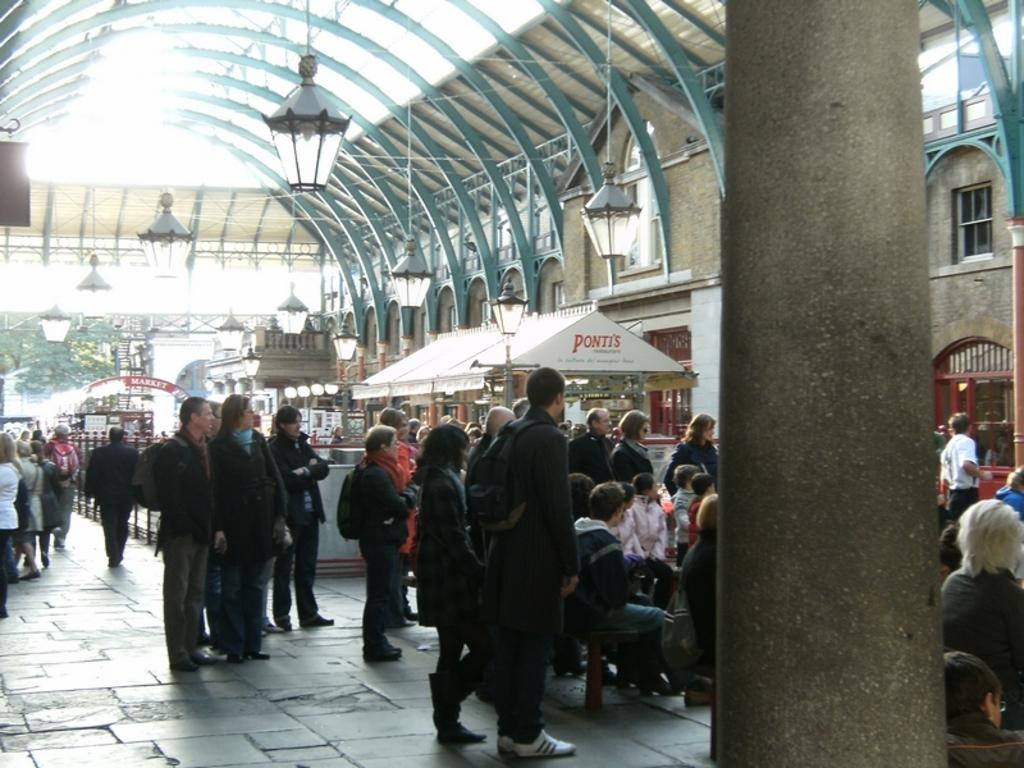<image>
Give a short and clear explanation of the subsequent image. People standing by a white canopy with red lettering of Ponti's on it. 